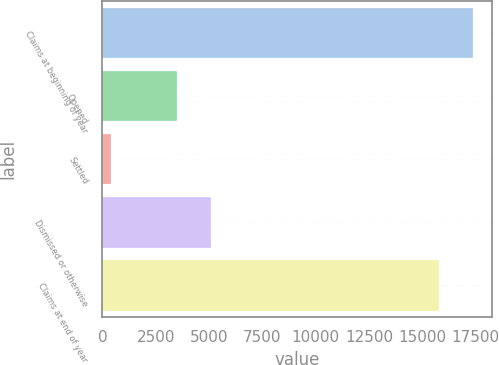Convert chart to OTSL. <chart><loc_0><loc_0><loc_500><loc_500><bar_chart><fcel>Claims at beginning of year<fcel>Opened<fcel>Settled<fcel>Dismissed or otherwise<fcel>Claims at end of year<nl><fcel>17385.7<fcel>3501<fcel>379<fcel>5095.7<fcel>15791<nl></chart> 